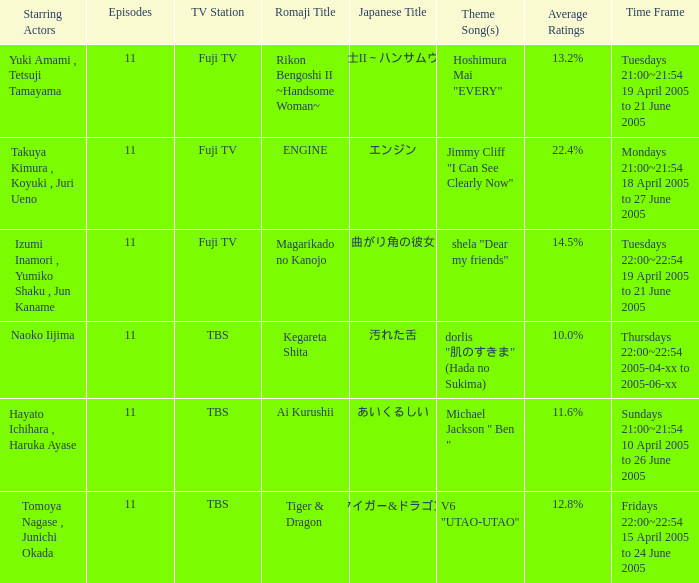What is the title with an average rating of 22.4%? ENGINE. 